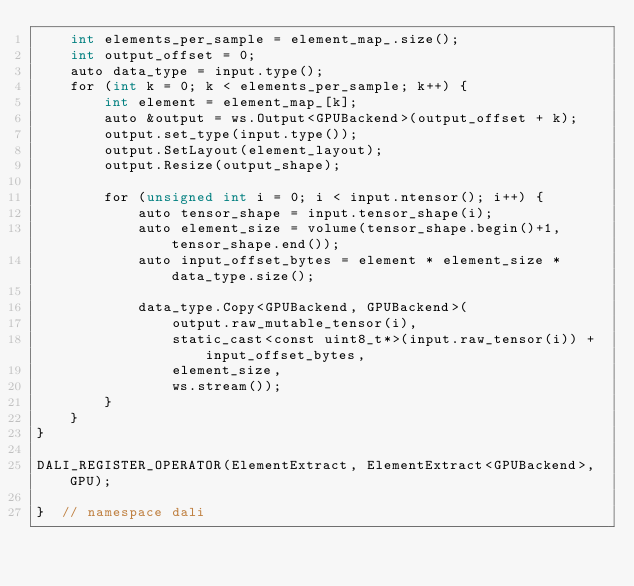<code> <loc_0><loc_0><loc_500><loc_500><_Cuda_>    int elements_per_sample = element_map_.size();
    int output_offset = 0;
    auto data_type = input.type();
    for (int k = 0; k < elements_per_sample; k++) {
        int element = element_map_[k];
        auto &output = ws.Output<GPUBackend>(output_offset + k);
        output.set_type(input.type());
        output.SetLayout(element_layout);
        output.Resize(output_shape);

        for (unsigned int i = 0; i < input.ntensor(); i++) {
            auto tensor_shape = input.tensor_shape(i);
            auto element_size = volume(tensor_shape.begin()+1, tensor_shape.end());
            auto input_offset_bytes = element * element_size * data_type.size();

            data_type.Copy<GPUBackend, GPUBackend>(
                output.raw_mutable_tensor(i),
                static_cast<const uint8_t*>(input.raw_tensor(i)) + input_offset_bytes,
                element_size,
                ws.stream());
        }
    }
}

DALI_REGISTER_OPERATOR(ElementExtract, ElementExtract<GPUBackend>, GPU);

}  // namespace dali
</code> 